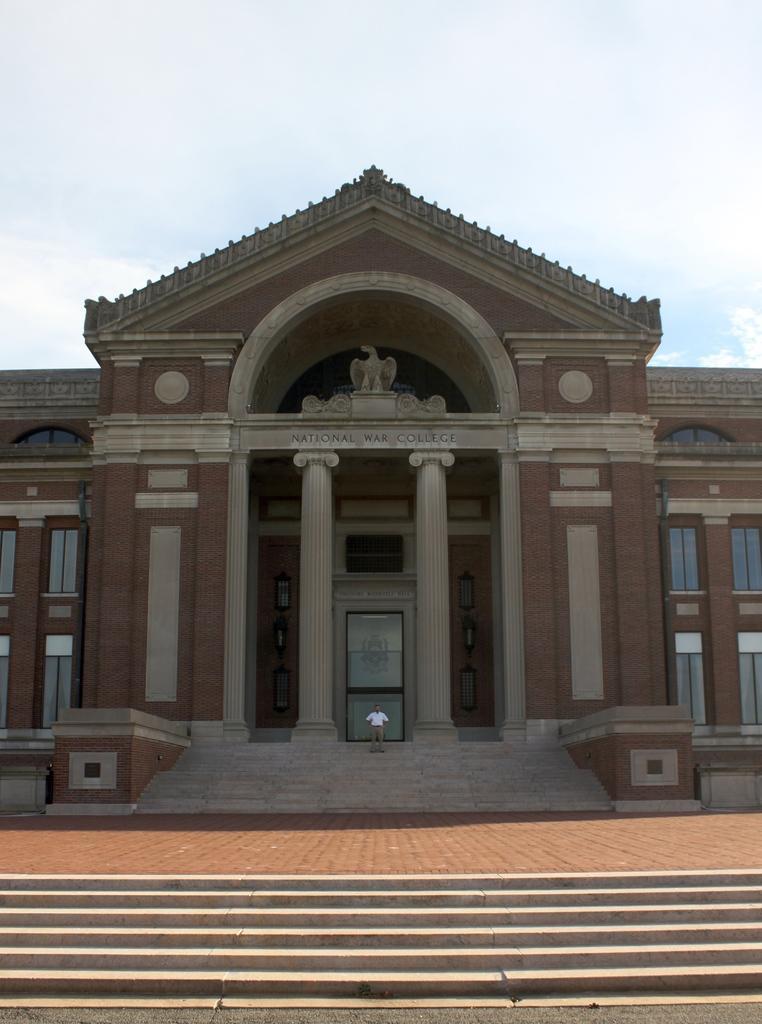Can you describe this image briefly? In this picture there is a national war college in the center of the image and there is a man who is standing on the stairs in the center of the image, there are stairs at the bottom side of the image and there is an eagle statue under the roof. 